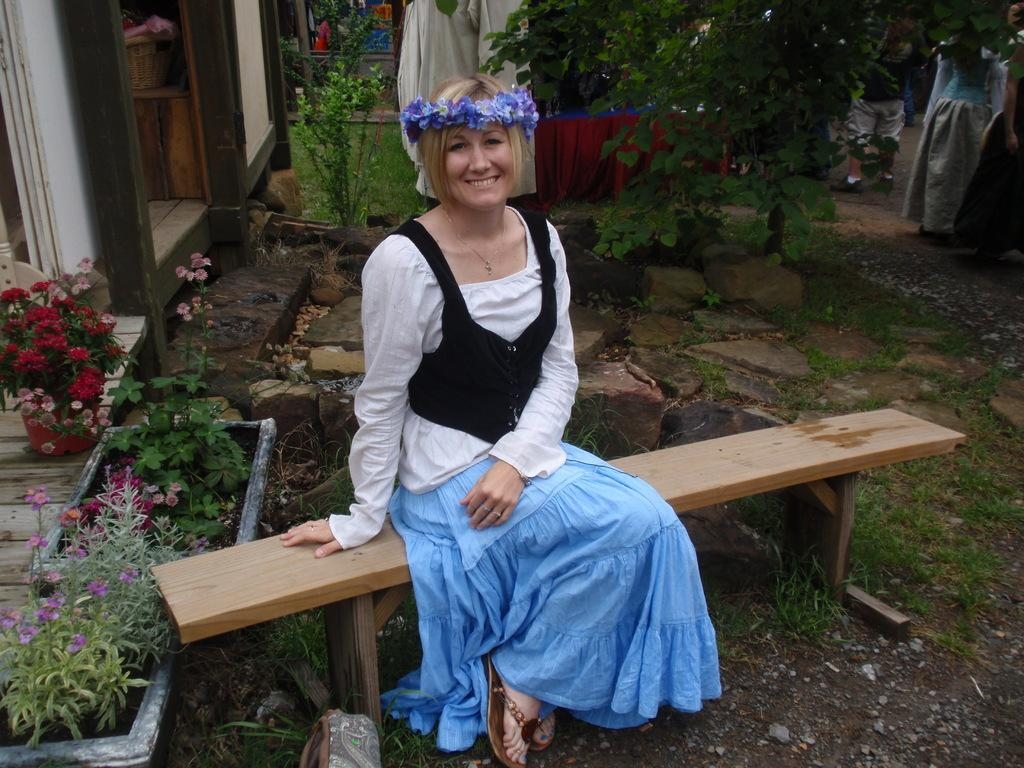What is the woman in the image doing? The woman is sitting on a bench in the image. What is the woman's facial expression? The woman is smiling. What can be seen in the background of the image? There are plants in the background of the image. What type of flowers are present in the image? There are red color flowers in the image. What type of vegetation is visible in the image? There is grass in the image. What type of chickens can be seen wearing shirts in the image? There are no chickens present in the image, let alone chickens wearing shirts. 